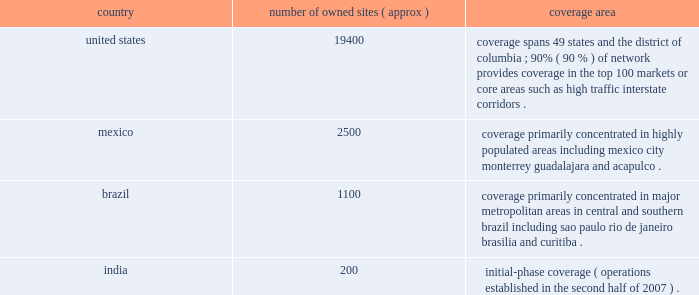( 201cati 201d ) and spectrasite communications , llc ( 201cspectrasite 201d ) .
We conduct our international operations through our subsidiary , american tower international , inc. , which in turn conducts operations through its various international operating subsidiaries .
Our international operations consist primarily of our operations in mexico and brazil , and also include operations in india , which we established in the second half of 2007 .
We operate in two business segments : rental and management and network development services .
For more information about our business segments , as well as financial information about the geographic areas in which we operate , see item 7 of this annual report under the caption 201cmanagement 2019s discussion and analysis of financial condition and results of operations 201d and note 18 to our consolidated financial statements included in this annual report .
Products and services rental and management our primary business is our communications site leasing business , which we conduct through our rental and management segment .
This segment accounted for approximately 97% ( 97 % ) , 98% ( 98 % ) and 98% ( 98 % ) of our total revenues for the years ended december 31 , 2008 , 2007 and 2006 , respectively .
Our rental and management segment is comprised of our domestic and international site leasing business , including the operation of wireless communications towers , broadcast communications towers and das networks , as well as rooftop management .
Wireless communications towers.we are a leading owner and operator of wireless communications towers in the united states , mexico and brazil , based on number of towers and revenue .
We also own and operate communications towers in india , where we commenced operations in the second half of 2007 .
In addition to owned wireless communications towers , we also manage wireless communications sites for property owners in the united states , mexico and brazil .
Approximately 92% ( 92 % ) , 91% ( 91 % ) and 91% ( 91 % ) of our rental and management segment revenue was attributable to our wireless communications towers for the years ended december 31 , 2008 , 2007 and 2006 , respectively .
As of december 31 , 2008 , our wireless communications tower portfolio included the following : country number of owned sites ( approx ) coverage area united states .
19400 coverage spans 49 states and the district of columbia ; 90% ( 90 % ) of network provides coverage in the top 100 markets or core areas such as high traffic interstate corridors .
Mexico .
2500 coverage primarily concentrated in highly populated areas , including mexico city , monterrey , guadalajara and acapulco .
Brazil .
1100 coverage primarily concentrated in major metropolitan areas in central and southern brazil , including sao paulo , rio de janeiro , brasilia and curitiba .
India .
200 initial-phase coverage ( operations established in the second half of 2007 ) .
We lease space on our wireless communications towers to customers in a diverse range of wireless industries , including personal communications services , cellular , enhanced specialized mobile radio , wimax .
Paging and fixed microwave .
Our major domestic wireless customers include at&t mobility , sprint nextel , verizon wireless ( which completed its merger with alltel in january 2009 ) and t-mobile usa .
Our major international wireless customers include grupo iusacell ( iusacell celular and unefon in mexico ) , nextel international in mexico and brazil , telefonica ( movistar in mexico and vivo in brazil ) , america movil ( telcel in mexico and claro in brazil ) and telecom italia mobile ( tim ) in brazil .
For the year ended december 31 .
( 201cati 201d ) and spectrasite communications , llc ( 201cspectrasite 201d ) .
We conduct our international operations through our subsidiary , american tower international , inc. , which in turn conducts operations through its various international operating subsidiaries .
Our international operations consist primarily of our operations in mexico and brazil , and also include operations in india , which we established in the second half of 2007 .
We operate in two business segments : rental and management and network development services .
For more information about our business segments , as well as financial information about the geographic areas in which we operate , see item 7 of this annual report under the caption 201cmanagement 2019s discussion and analysis of financial condition and results of operations 201d and note 18 to our consolidated financial statements included in this annual report .
Products and services rental and management our primary business is our communications site leasing business , which we conduct through our rental and management segment .
This segment accounted for approximately 97% ( 97 % ) , 98% ( 98 % ) and 98% ( 98 % ) of our total revenues for the years ended december 31 , 2008 , 2007 and 2006 , respectively .
Our rental and management segment is comprised of our domestic and international site leasing business , including the operation of wireless communications towers , broadcast communications towers and das networks , as well as rooftop management .
Wireless communications towers.we are a leading owner and operator of wireless communications towers in the united states , mexico and brazil , based on number of towers and revenue .
We also own and operate communications towers in india , where we commenced operations in the second half of 2007 .
In addition to owned wireless communications towers , we also manage wireless communications sites for property owners in the united states , mexico and brazil .
Approximately 92% ( 92 % ) , 91% ( 91 % ) and 91% ( 91 % ) of our rental and management segment revenue was attributable to our wireless communications towers for the years ended december 31 , 2008 , 2007 and 2006 , respectively .
As of december 31 , 2008 , our wireless communications tower portfolio included the following : country number of owned sites ( approx ) coverage area united states .
19400 coverage spans 49 states and the district of columbia ; 90% ( 90 % ) of network provides coverage in the top 100 markets or core areas such as high traffic interstate corridors .
Mexico .
2500 coverage primarily concentrated in highly populated areas , including mexico city , monterrey , guadalajara and acapulco .
Brazil .
1100 coverage primarily concentrated in major metropolitan areas in central and southern brazil , including sao paulo , rio de janeiro , brasilia and curitiba .
India .
200 initial-phase coverage ( operations established in the second half of 2007 ) .
We lease space on our wireless communications towers to customers in a diverse range of wireless industries , including personal communications services , cellular , enhanced specialized mobile radio , wimax .
Paging and fixed microwave .
Our major domestic wireless customers include at&t mobility , sprint nextel , verizon wireless ( which completed its merger with alltel in january 2009 ) and t-mobile usa .
Our major international wireless customers include grupo iusacell ( iusacell celular and unefon in mexico ) , nextel international in mexico and brazil , telefonica ( movistar in mexico and vivo in brazil ) , america movil ( telcel in mexico and claro in brazil ) and telecom italia mobile ( tim ) in brazil .
For the year ended december 31 .
What is the total number of owned sites presented in the table? 
Computations: (((19400 + 2500) + 1100) + 200)
Answer: 23200.0. 